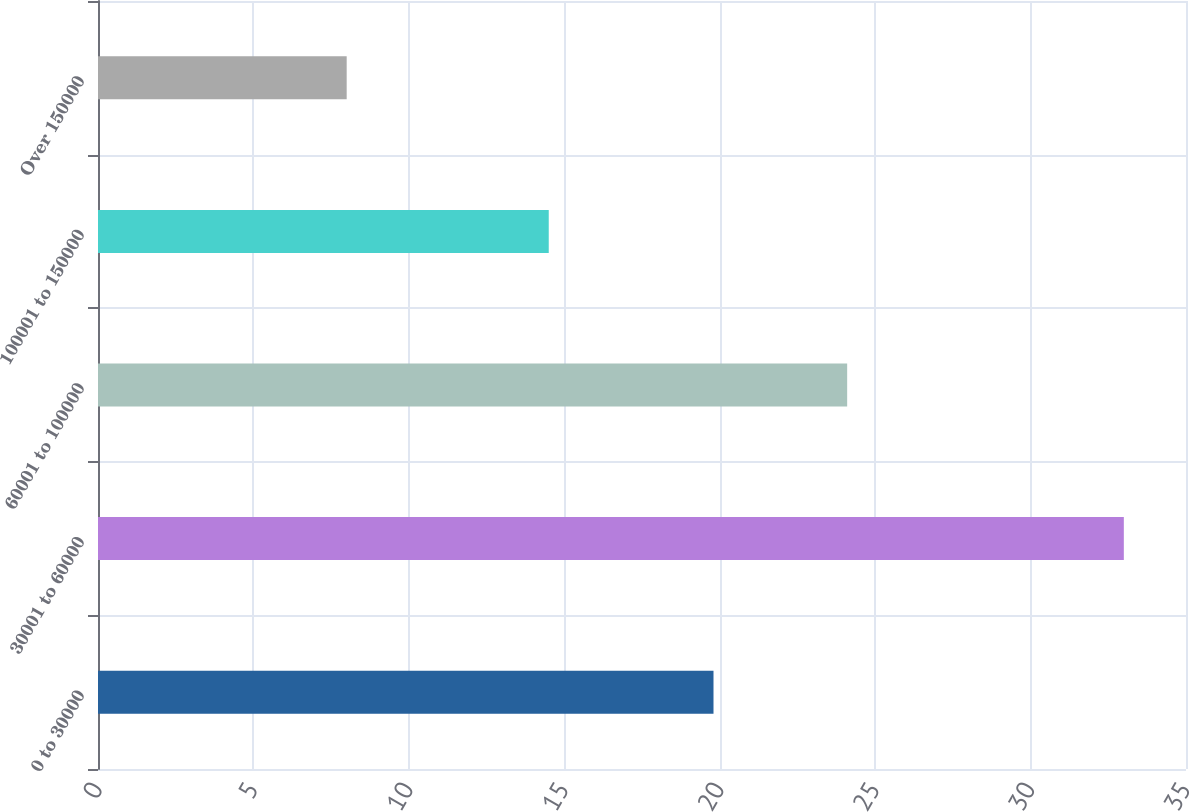<chart> <loc_0><loc_0><loc_500><loc_500><bar_chart><fcel>0 to 30000<fcel>30001 to 60000<fcel>60001 to 100000<fcel>100001 to 150000<fcel>Over 150000<nl><fcel>19.8<fcel>33<fcel>24.1<fcel>14.5<fcel>8<nl></chart> 